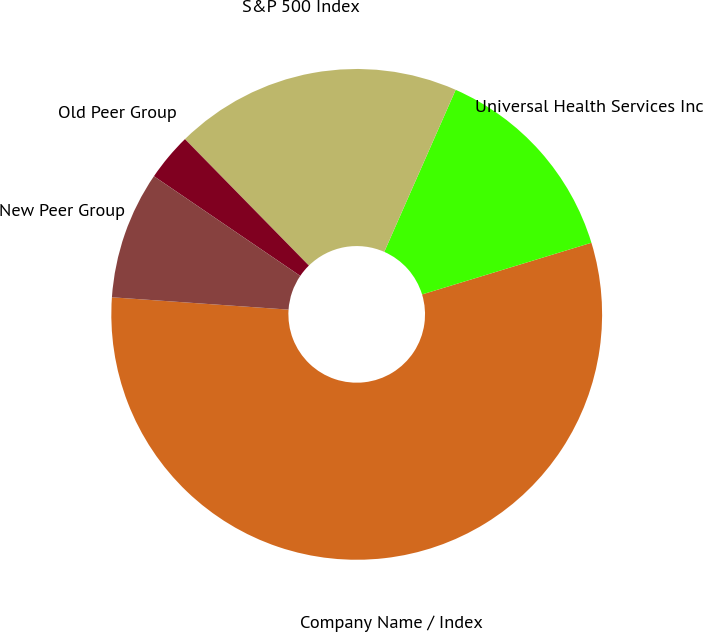Convert chart. <chart><loc_0><loc_0><loc_500><loc_500><pie_chart><fcel>Company Name / Index<fcel>Universal Health Services Inc<fcel>S&P 500 Index<fcel>Old Peer Group<fcel>New Peer Group<nl><fcel>55.83%<fcel>13.68%<fcel>18.95%<fcel>3.14%<fcel>8.41%<nl></chart> 